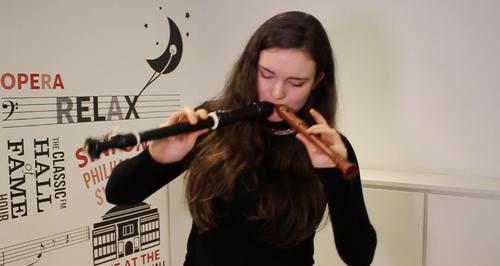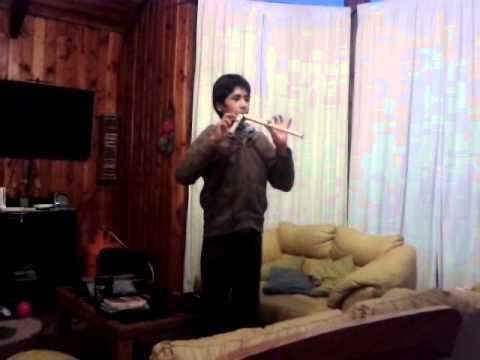The first image is the image on the left, the second image is the image on the right. Analyze the images presented: Is the assertion "In the right image, a male is holding two flute-like instruments to his mouth so they form a V-shape." valid? Answer yes or no. Yes. The first image is the image on the left, the second image is the image on the right. Evaluate the accuracy of this statement regarding the images: "Each musician is holding two instruments.". Is it true? Answer yes or no. Yes. 